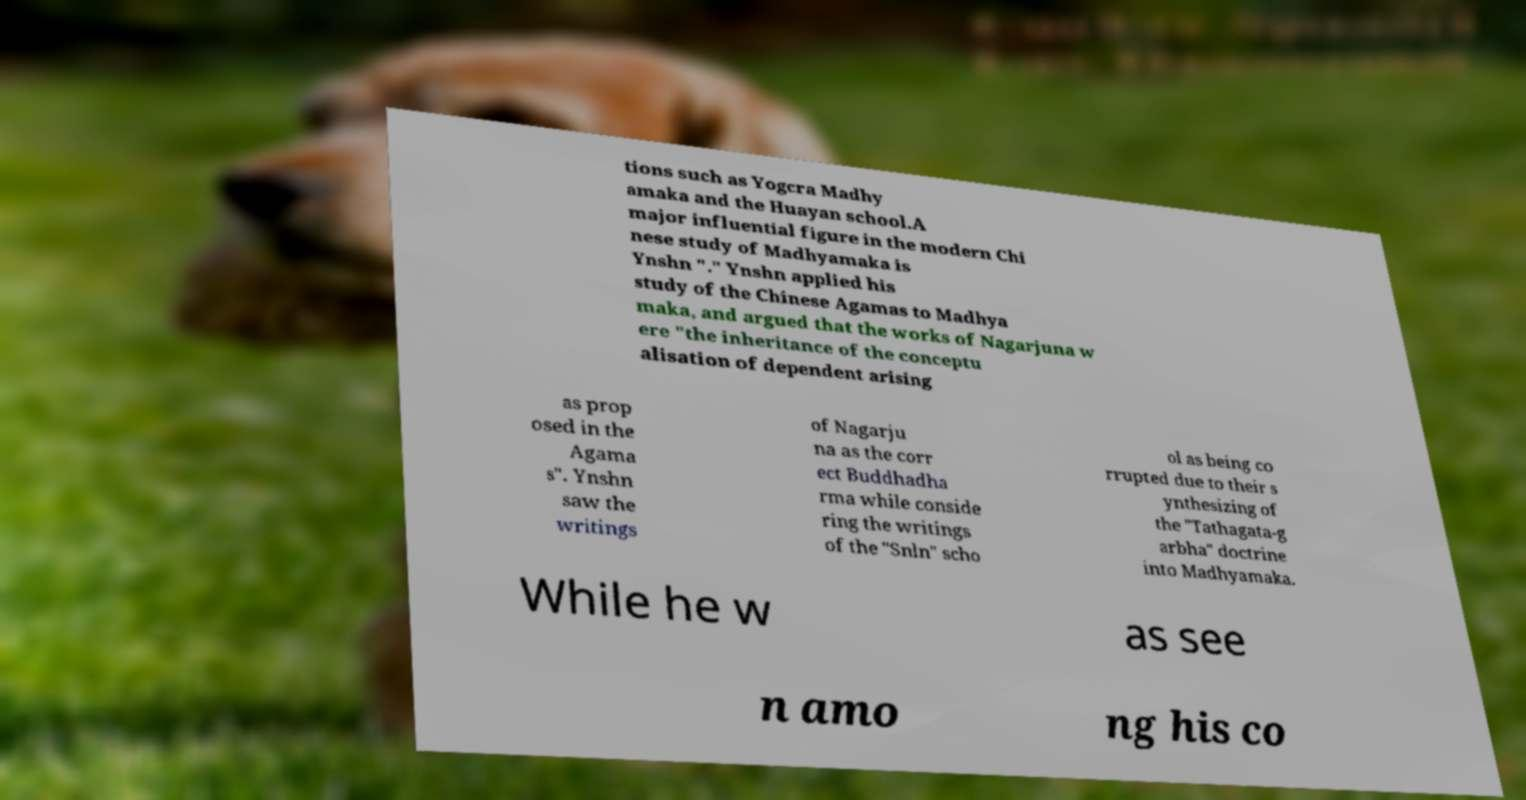What messages or text are displayed in this image? I need them in a readable, typed format. tions such as Yogcra Madhy amaka and the Huayan school.A major influential figure in the modern Chi nese study of Madhyamaka is Ynshn "." Ynshn applied his study of the Chinese Agamas to Madhya maka, and argued that the works of Nagarjuna w ere "the inheritance of the conceptu alisation of dependent arising as prop osed in the Agama s". Ynshn saw the writings of Nagarju na as the corr ect Buddhadha rma while conside ring the writings of the "Snln" scho ol as being co rrupted due to their s ynthesizing of the "Tathagata-g arbha" doctrine into Madhyamaka. While he w as see n amo ng his co 